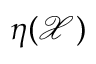Convert formula to latex. <formula><loc_0><loc_0><loc_500><loc_500>\eta ( \mathcal { X } )</formula> 